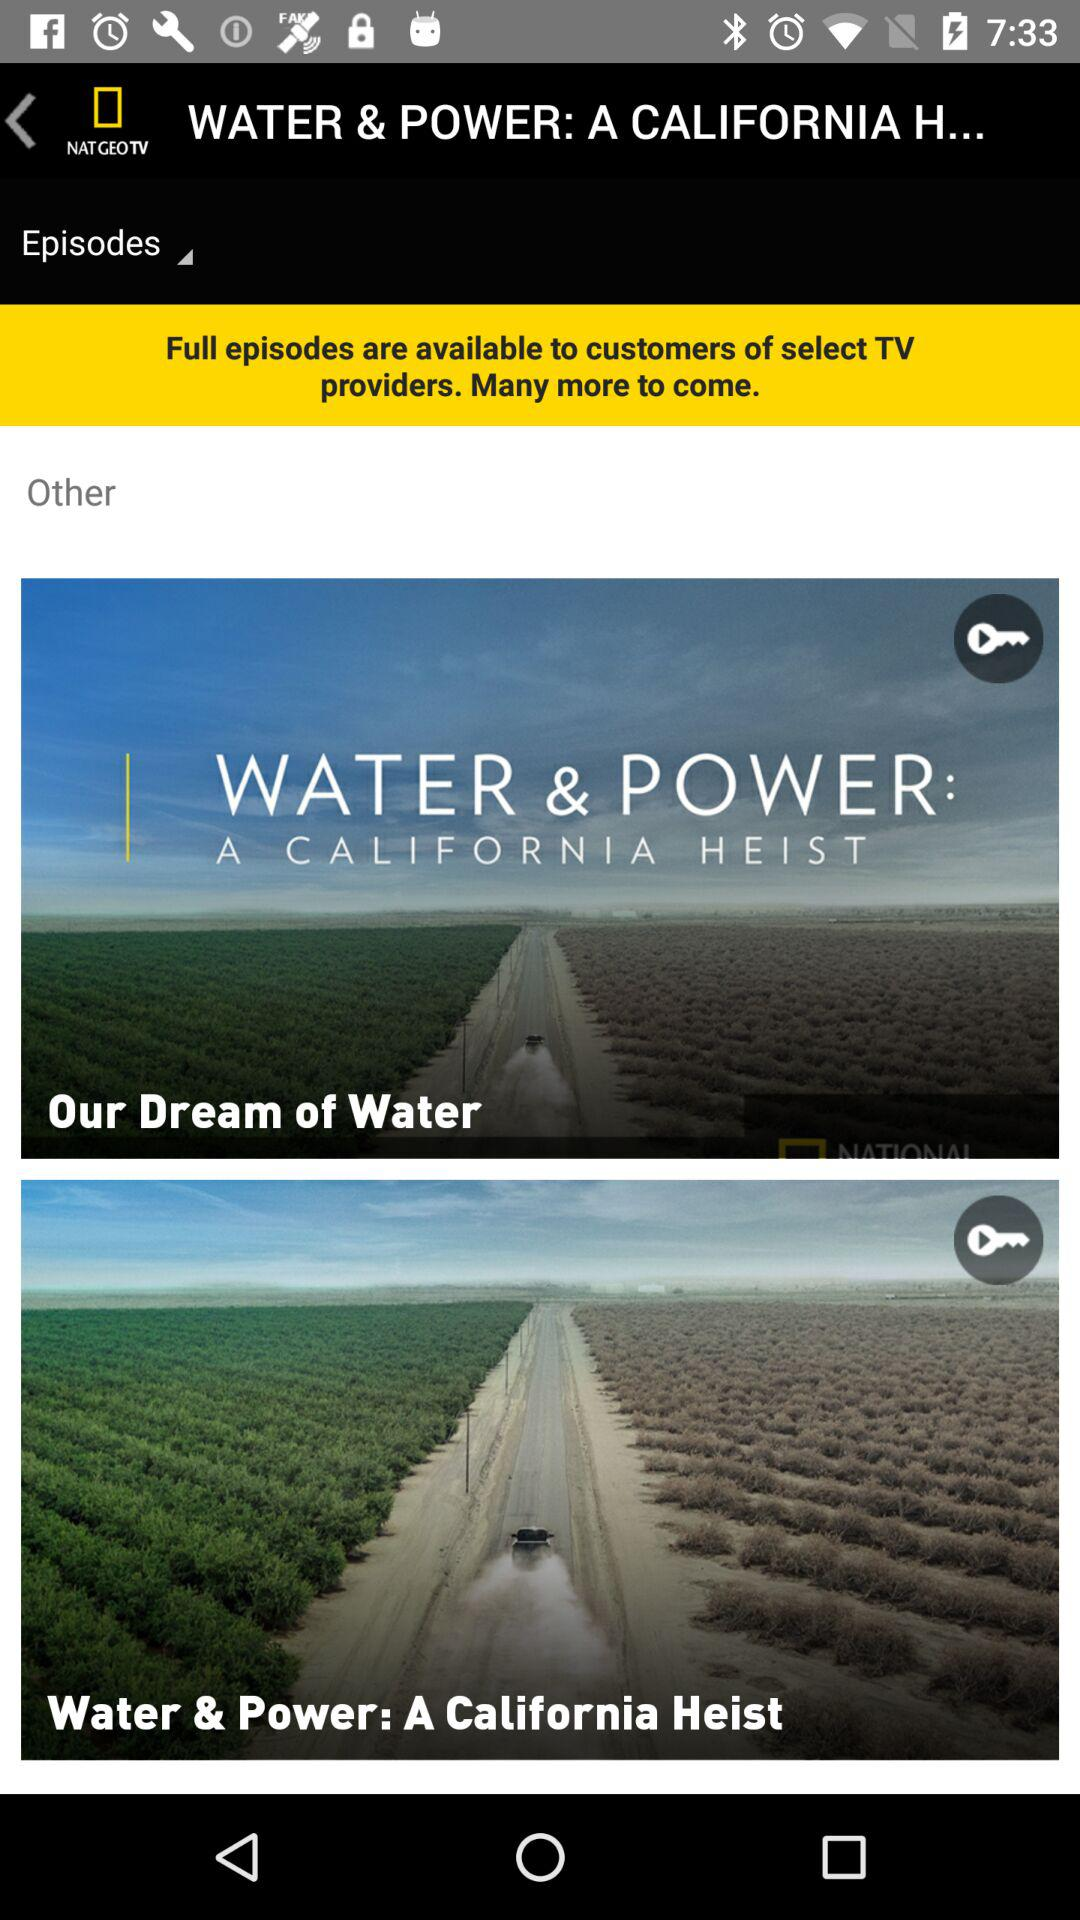When was "Our Dream of Water" uploaded?
When the provided information is insufficient, respond with <no answer>. <no answer> 